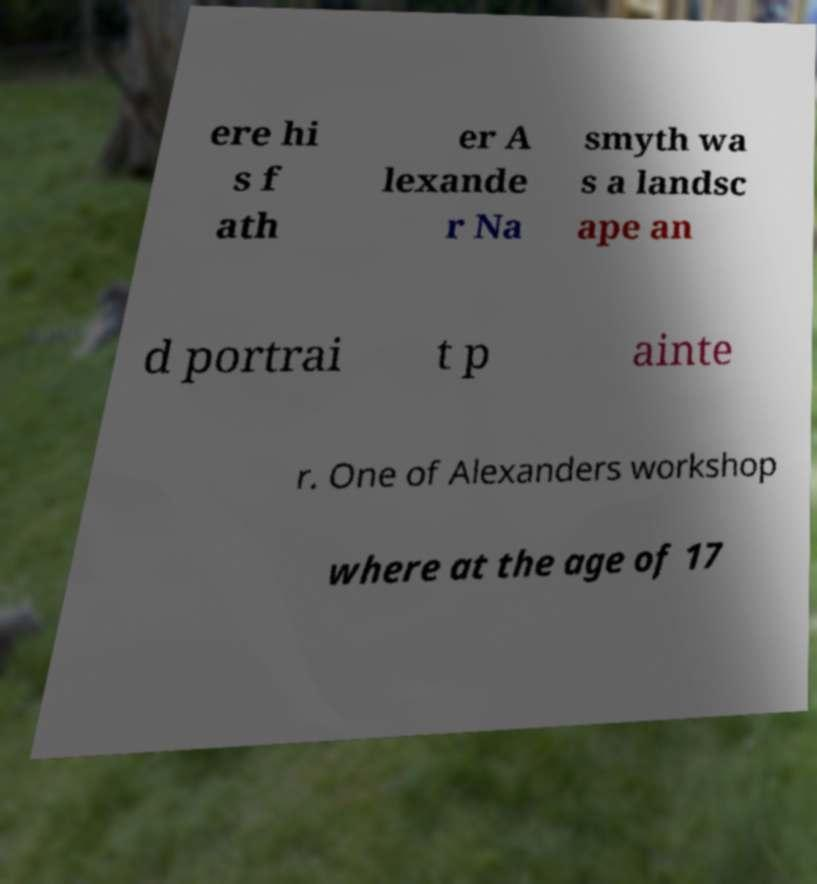Please read and relay the text visible in this image. What does it say? ere hi s f ath er A lexande r Na smyth wa s a landsc ape an d portrai t p ainte r. One of Alexanders workshop where at the age of 17 